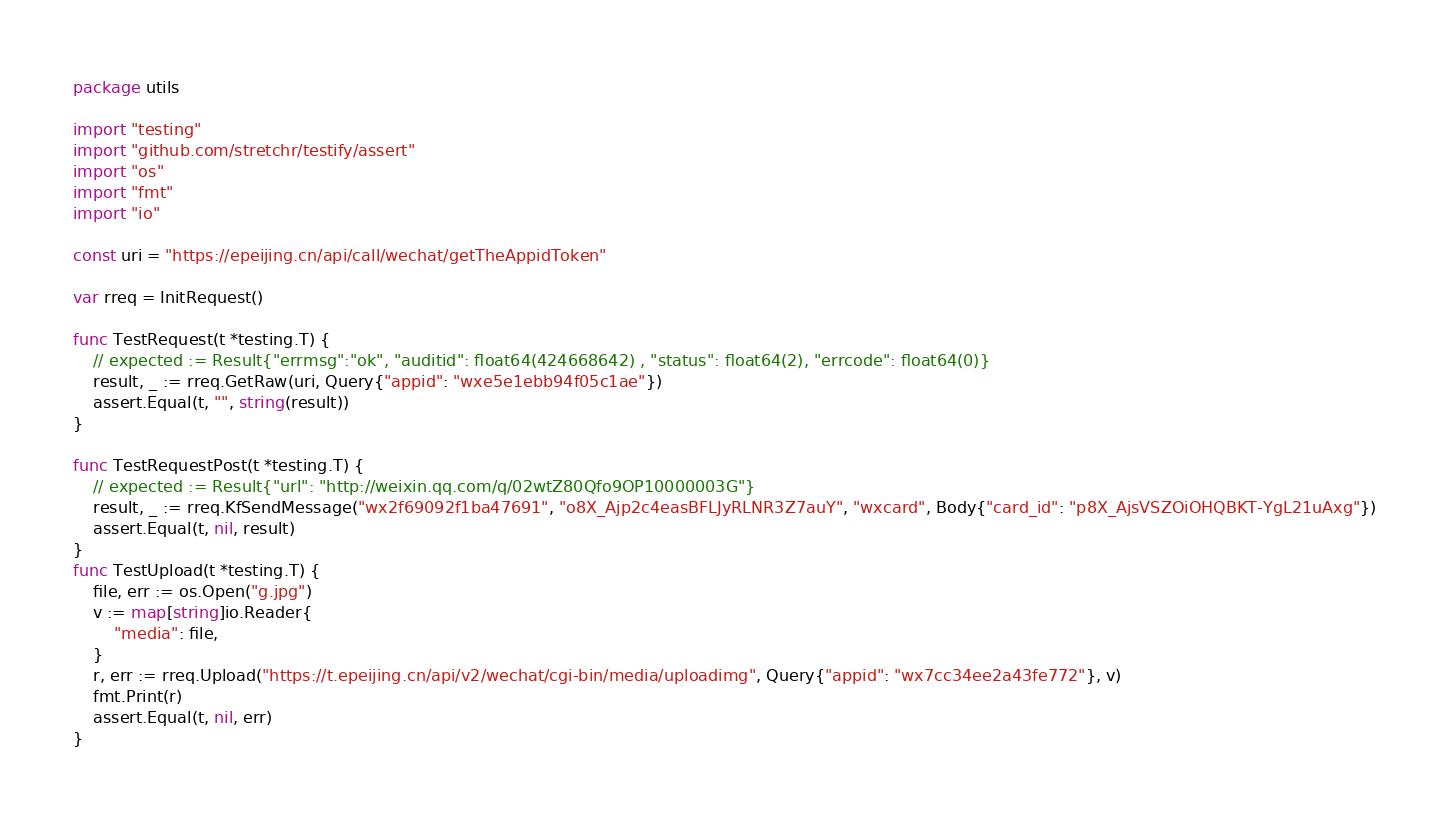Convert code to text. <code><loc_0><loc_0><loc_500><loc_500><_Go_>package utils

import "testing"
import "github.com/stretchr/testify/assert"
import "os"
import "fmt"
import "io"

const uri = "https://epeijing.cn/api/call/wechat/getTheAppidToken"

var rreq = InitRequest()

func TestRequest(t *testing.T) {
	// expected := Result{"errmsg":"ok", "auditid": float64(424668642) , "status": float64(2), "errcode": float64(0)}
	result, _ := rreq.GetRaw(uri, Query{"appid": "wxe5e1ebb94f05c1ae"})
	assert.Equal(t, "", string(result))
}

func TestRequestPost(t *testing.T) {
	// expected := Result{"url": "http://weixin.qq.com/q/02wtZ80Qfo9OP10000003G"}
	result, _ := rreq.KfSendMessage("wx2f69092f1ba47691", "o8X_Ajp2c4easBFLJyRLNR3Z7auY", "wxcard", Body{"card_id": "p8X_AjsVSZOiOHQBKT-YgL21uAxg"})
	assert.Equal(t, nil, result)
}
func TestUpload(t *testing.T) {
	file, err := os.Open("g.jpg")
	v := map[string]io.Reader{
		"media": file,
	}
	r, err := rreq.Upload("https://t.epeijing.cn/api/v2/wechat/cgi-bin/media/uploadimg", Query{"appid": "wx7cc34ee2a43fe772"}, v)
	fmt.Print(r)
	assert.Equal(t, nil, err)
}
</code> 